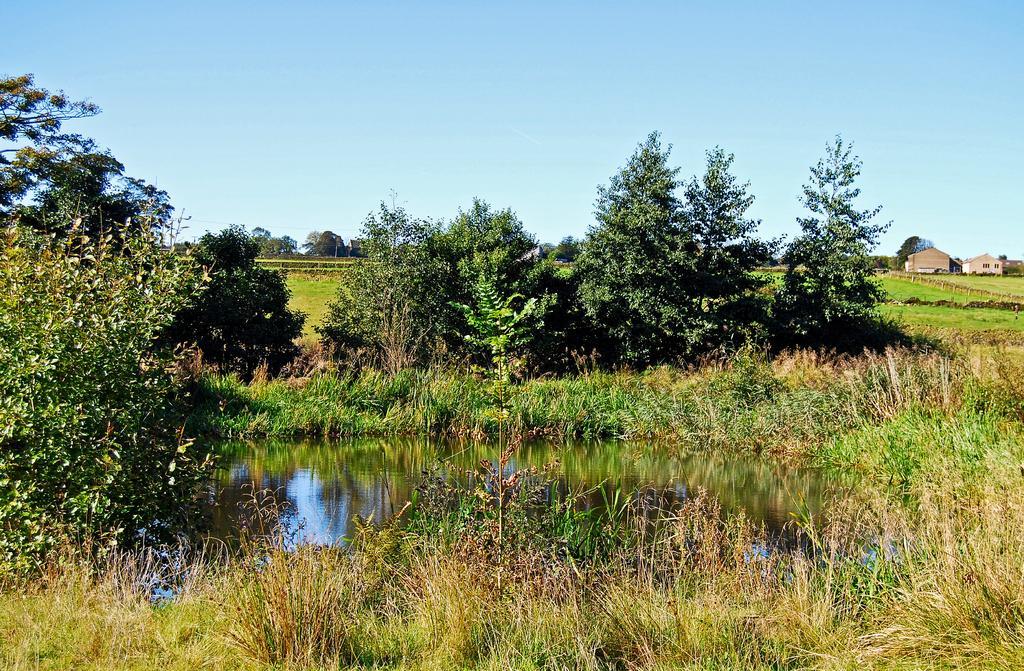Describe this image in one or two sentences. In the center of the image there are trees. At the bottom there is a pond and grass. On the right there are sheds. At the top there is sky. 